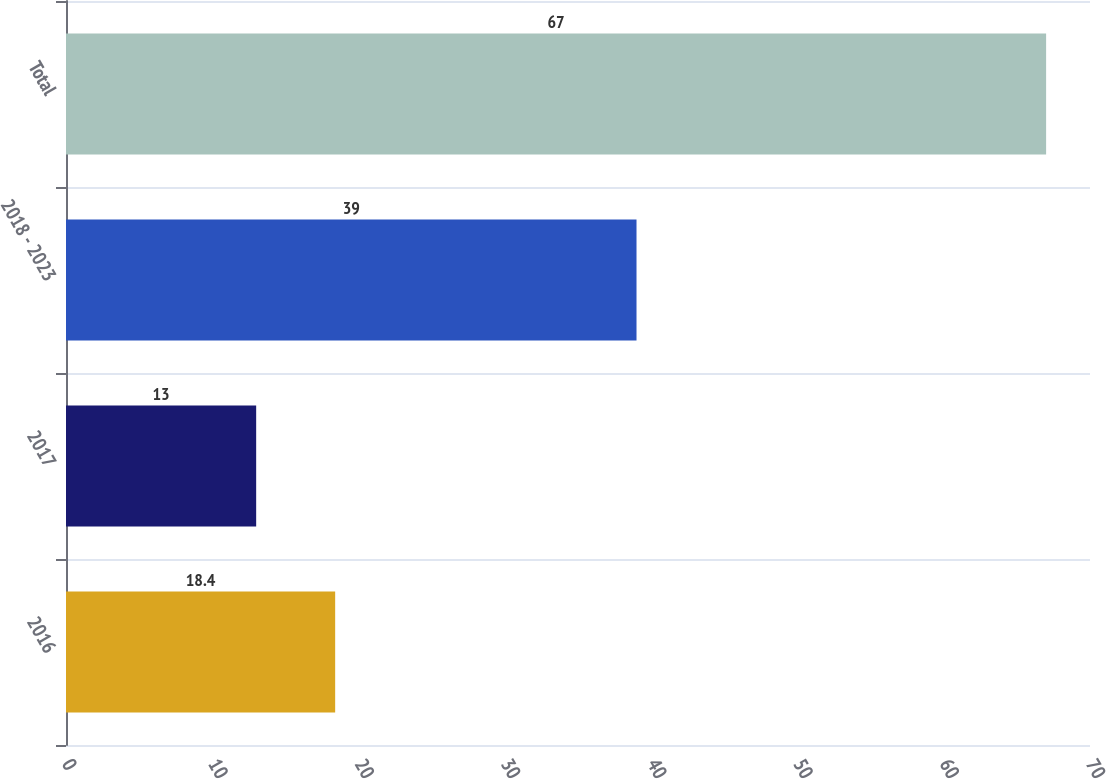Convert chart to OTSL. <chart><loc_0><loc_0><loc_500><loc_500><bar_chart><fcel>2016<fcel>2017<fcel>2018 - 2023<fcel>Total<nl><fcel>18.4<fcel>13<fcel>39<fcel>67<nl></chart> 